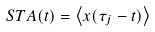Convert formula to latex. <formula><loc_0><loc_0><loc_500><loc_500>S T A ( t ) = \left < x ( \tau _ { j } - t ) \right ></formula> 